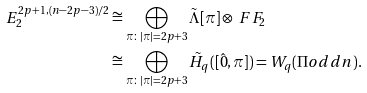<formula> <loc_0><loc_0><loc_500><loc_500>E _ { 2 } ^ { 2 p + 1 , ( n - 2 p - 3 ) / 2 } & \cong \bigoplus _ { \pi \colon | \pi | = 2 p + 3 } \tilde { \Lambda } [ \pi ] \otimes \ F F _ { 2 } \\ & \cong \bigoplus _ { \pi \colon | \pi | = 2 p + 3 } \tilde { H } _ { q } ( [ \hat { 0 } , \pi ] ) = W _ { q } ( \Pi o d d { n } ) .</formula> 